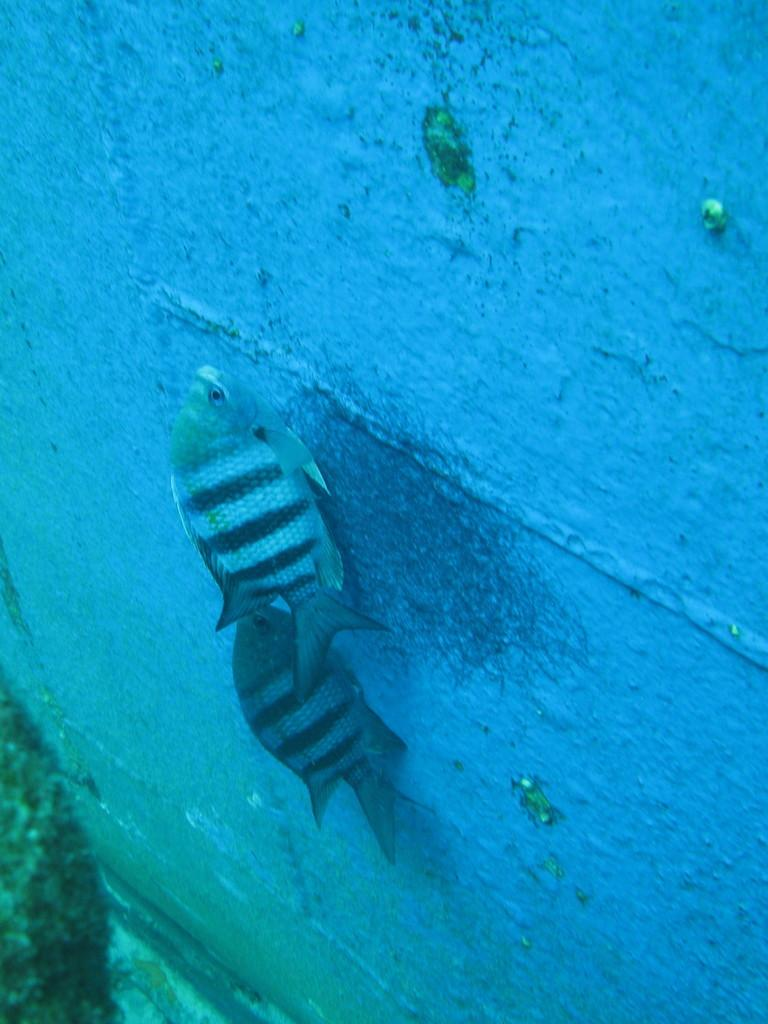What type of animals can be seen in the image? There are fishes in the image. What is the primary element in the background of the image? There is a wall in the background of the image. What type of snails can be seen crawling on the wall in the image? There are no snails present in the image; it features fishes and a wall. What type of teeth can be seen on the fishes in the image? Fishes do not have teeth like mammals, so there are no teeth visible on the fishes in the image. 